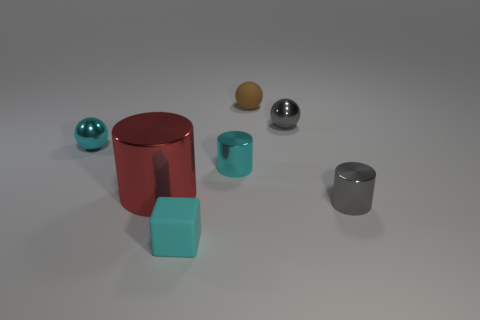There is a metallic sphere that is to the left of the small rubber cube; how many cyan metallic objects are behind it?
Provide a short and direct response. 0. There is a gray cylinder that is in front of the tiny gray sphere right of the small cyan shiny cylinder; are there any small shiny balls that are right of it?
Provide a short and direct response. No. What material is the cyan object that is the same shape as the red shiny object?
Make the answer very short. Metal. Does the small brown sphere have the same material as the tiny cylinder that is left of the small brown thing?
Ensure brevity in your answer.  No. The small cyan metallic object to the right of the shiny ball left of the small cube is what shape?
Keep it short and to the point. Cylinder. How many small things are either gray metallic objects or red rubber cylinders?
Offer a very short reply. 2. What number of tiny gray metal things are the same shape as the brown matte thing?
Your answer should be compact. 1. Does the big red metallic object have the same shape as the small gray object that is behind the big shiny object?
Your response must be concise. No. What number of tiny gray cylinders are on the left side of the tiny gray shiny cylinder?
Give a very brief answer. 0. Is there a red object of the same size as the red cylinder?
Your answer should be very brief. No. 